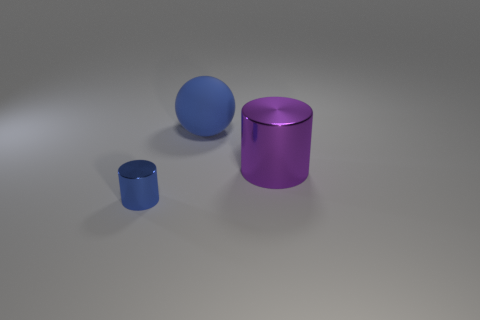There is a thing that is the same color as the ball; what is its material?
Your answer should be compact. Metal. How many objects are either tiny metallic objects or things on the right side of the tiny blue cylinder?
Your response must be concise. 3. How many purple cylinders are to the right of the metallic cylinder that is behind the metal cylinder that is on the left side of the large cylinder?
Ensure brevity in your answer.  0. There is a sphere that is the same size as the purple object; what material is it?
Offer a very short reply. Rubber. Are there any matte objects that have the same size as the purple metal cylinder?
Ensure brevity in your answer.  Yes. The sphere has what color?
Offer a terse response. Blue. What color is the cylinder that is on the right side of the blue object left of the large blue matte object?
Provide a succinct answer. Purple. What is the shape of the big object that is behind the cylinder on the right side of the shiny thing on the left side of the purple shiny thing?
Your response must be concise. Sphere. How many other purple cylinders have the same material as the small cylinder?
Your answer should be compact. 1. What number of big blue things are in front of the cylinder that is in front of the big metal cylinder?
Your response must be concise. 0. 